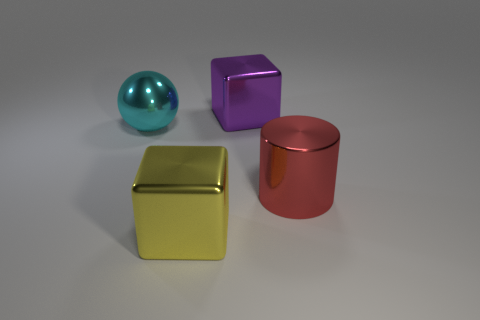Add 1 metal blocks. How many objects exist? 5 Subtract all cylinders. How many objects are left? 3 Add 1 large cyan things. How many large cyan things are left? 2 Add 2 tiny cyan metallic cylinders. How many tiny cyan metallic cylinders exist? 2 Subtract 0 gray blocks. How many objects are left? 4 Subtract all purple blocks. Subtract all red things. How many objects are left? 2 